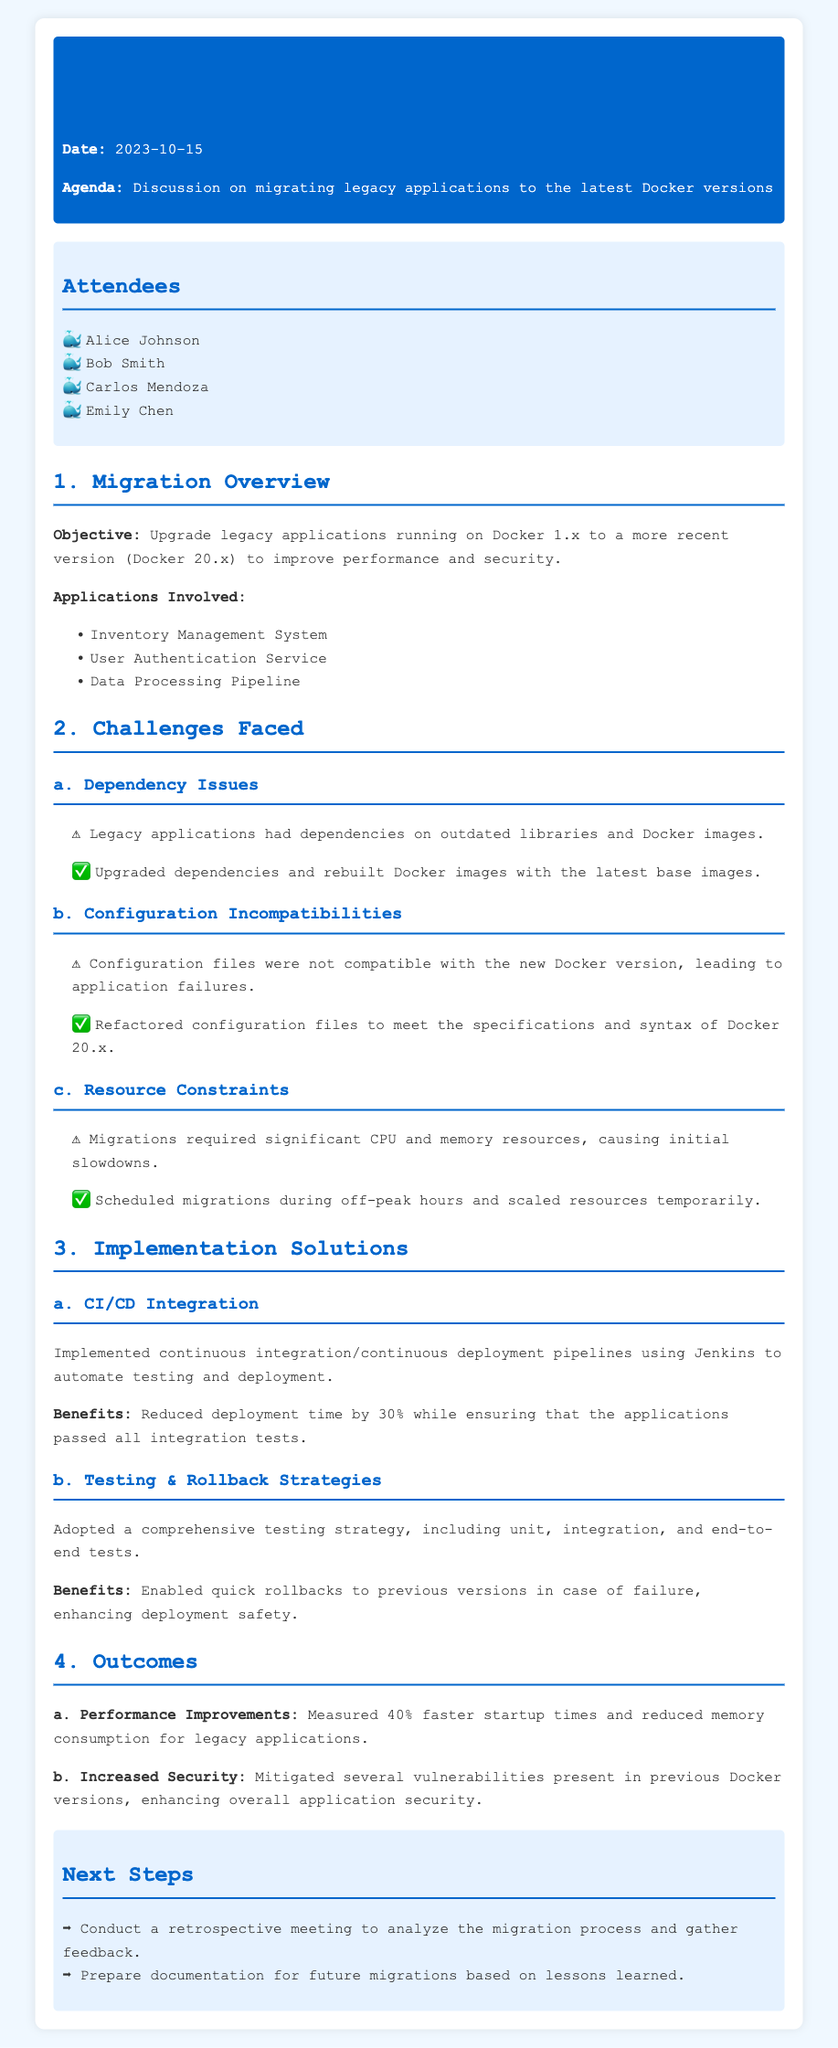what is the date of the meeting? The date is explicitly mentioned in the header of the document.
Answer: 2023-10-15 who were the attendees of the meeting? A list of attendees is provided in the document under the attendees section.
Answer: Alice Johnson, Bob Smith, Carlos Mendoza, Emily Chen what versions of Docker were the legacy applications using prior to the migration? The document specifies the previous version of Docker before the migration.
Answer: Docker 1.x what applications were involved in the migration? A list of applications involved in the migration is provided in the overview section.
Answer: Inventory Management System, User Authentication Service, Data Processing Pipeline what was one of the challenges faced during migration? The document lists challenges faced during migration, which include dependency issues and configuration incompatibilities.
Answer: Dependency Issues how much faster were the startup times after migration? The document provides quantified performance improvements following the migration.
Answer: 40% faster what benefit did CI/CD integration provide? A specific benefit of implementing CI/CD integration is mentioned.
Answer: Reduced deployment time by 30% what is the next step mentioned in the document? The document outlines next steps to be taken following the migration.
Answer: Conduct a retrospective meeting 